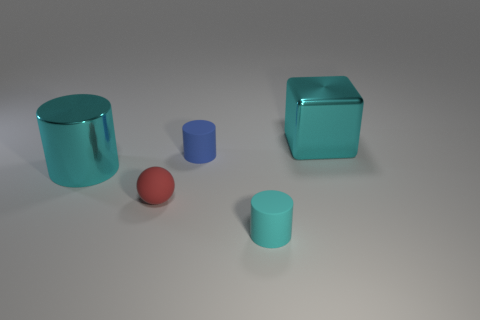Which of these objects appears to be the largest? The largest object appears to be the blue cube due to its height, width, and depth dimensions. 